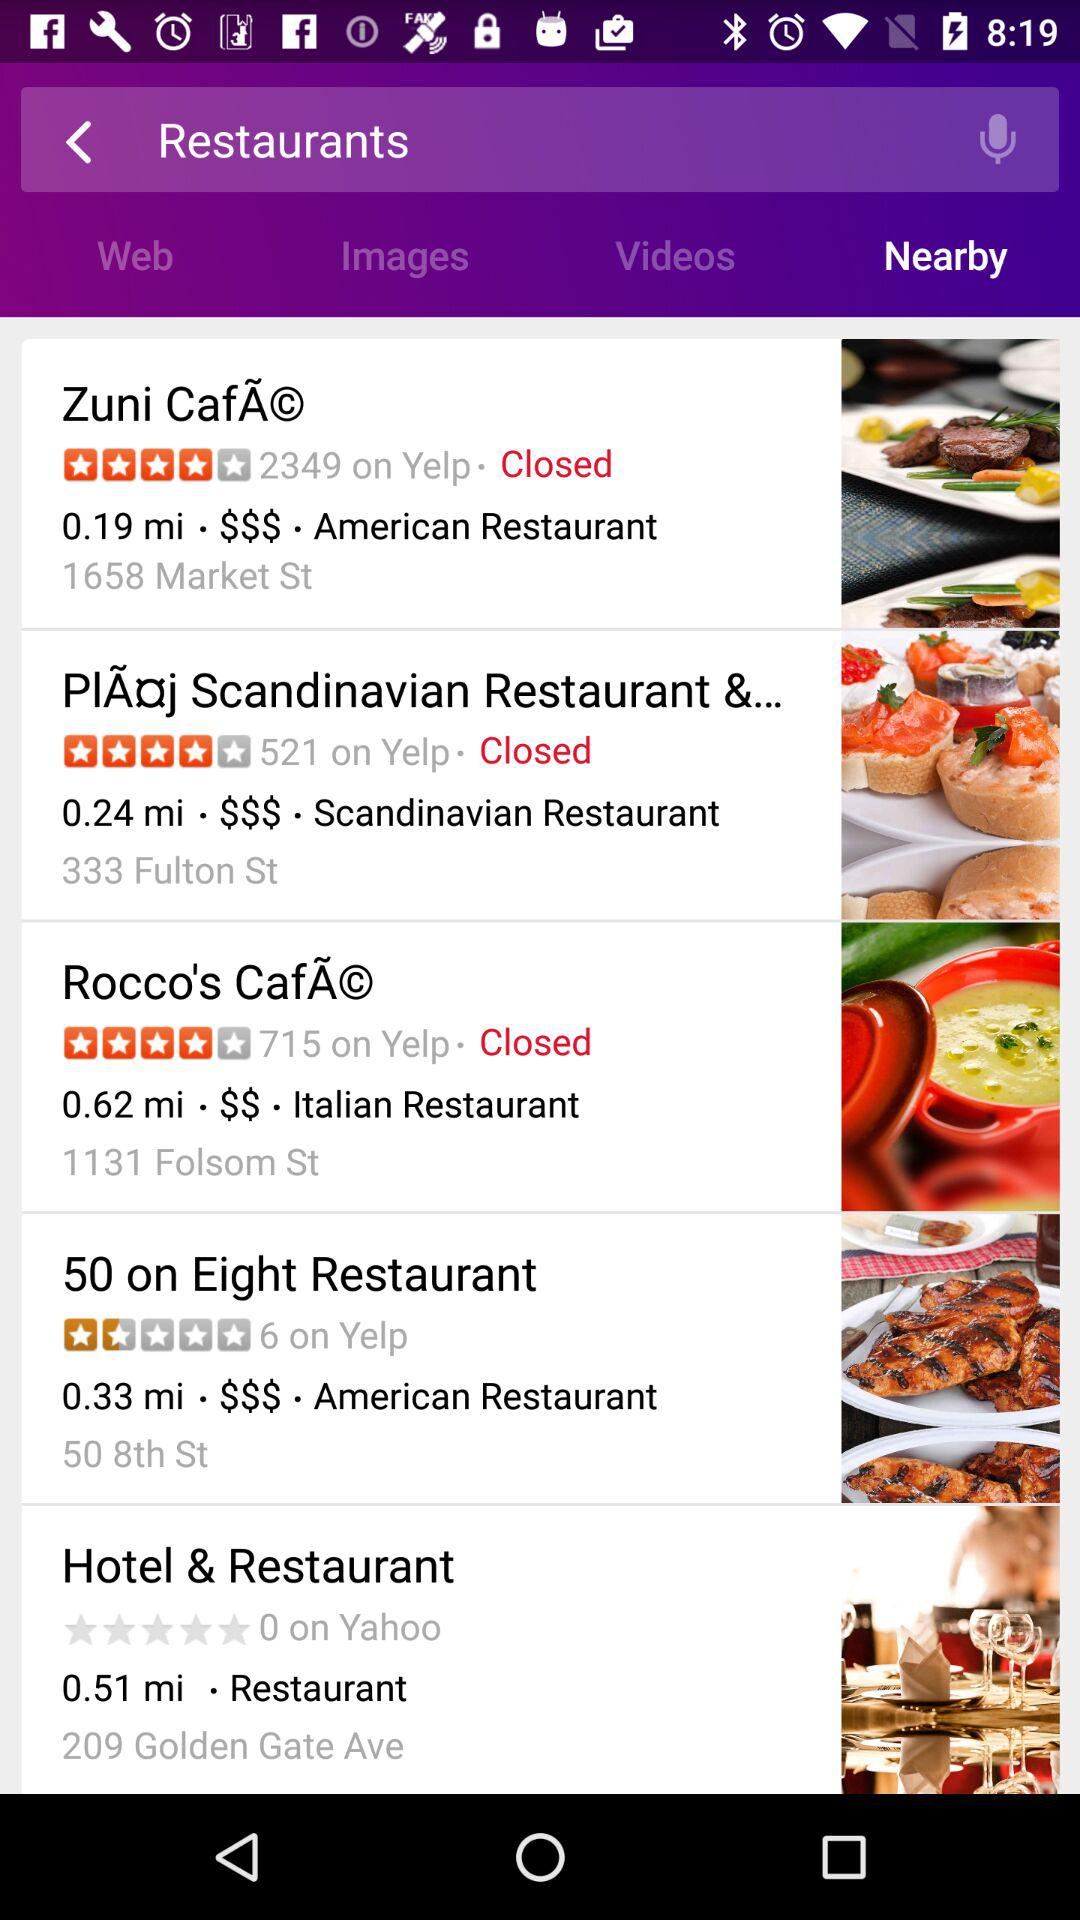What is the rating for the hotel and restaurant on Yahoo? The rating for the hotel and restaurant on Yahoo is 0. 